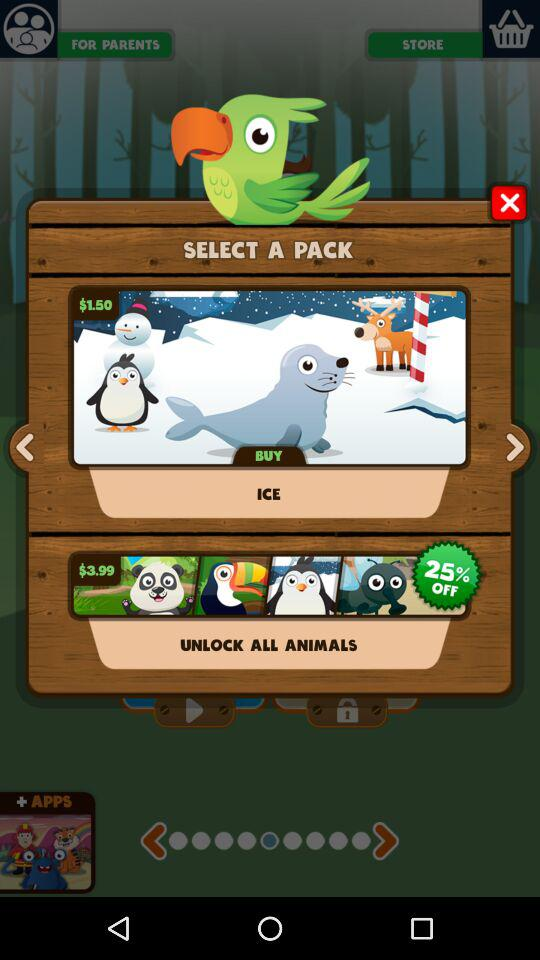How much more does the Unlock All Animals pack cost than the Ice pack?
Answer the question using a single word or phrase. $2.49 